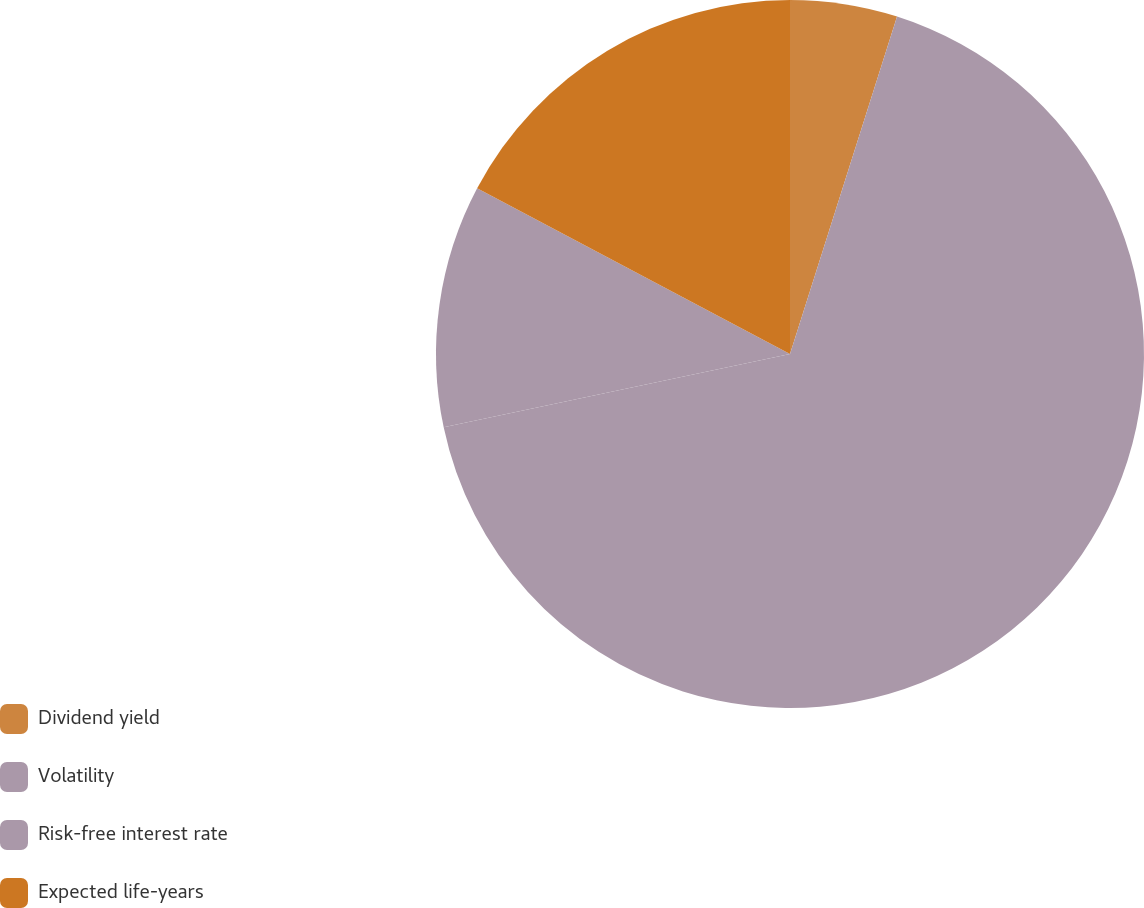Convert chart. <chart><loc_0><loc_0><loc_500><loc_500><pie_chart><fcel>Dividend yield<fcel>Volatility<fcel>Risk-free interest rate<fcel>Expected life-years<nl><fcel>4.89%<fcel>66.79%<fcel>11.07%<fcel>17.25%<nl></chart> 